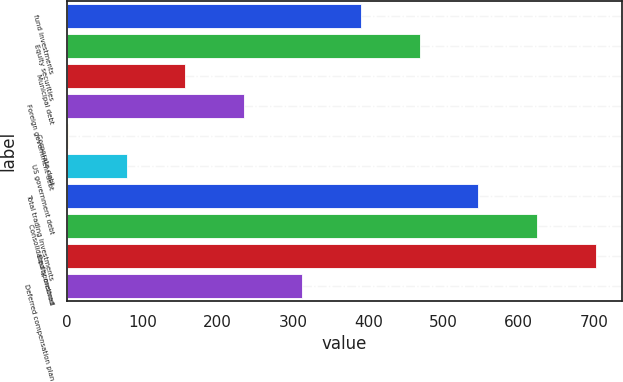<chart> <loc_0><loc_0><loc_500><loc_500><bar_chart><fcel>fund investments<fcel>Equity securities<fcel>Municipal debt<fcel>Foreign government debt<fcel>Corporate debt<fcel>US government debt<fcel>Total trading investments<fcel>Consolidated sponsored<fcel>Equity method<fcel>Deferred compensation plan<nl><fcel>390.5<fcel>468.4<fcel>156.8<fcel>234.7<fcel>1<fcel>78.9<fcel>546.3<fcel>624.2<fcel>702.1<fcel>312.6<nl></chart> 